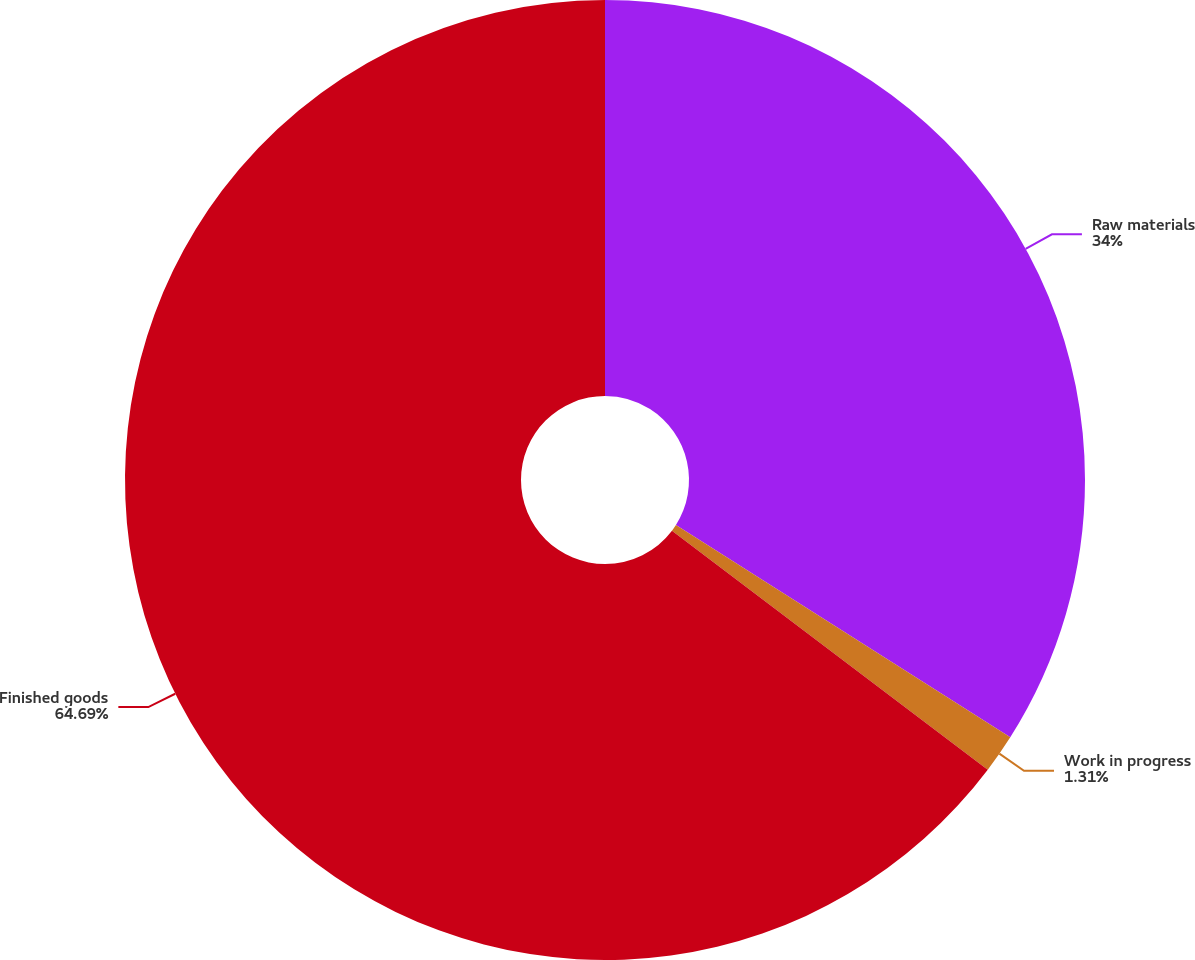Convert chart to OTSL. <chart><loc_0><loc_0><loc_500><loc_500><pie_chart><fcel>Raw materials<fcel>Work in progress<fcel>Finished goods<nl><fcel>34.0%<fcel>1.31%<fcel>64.69%<nl></chart> 